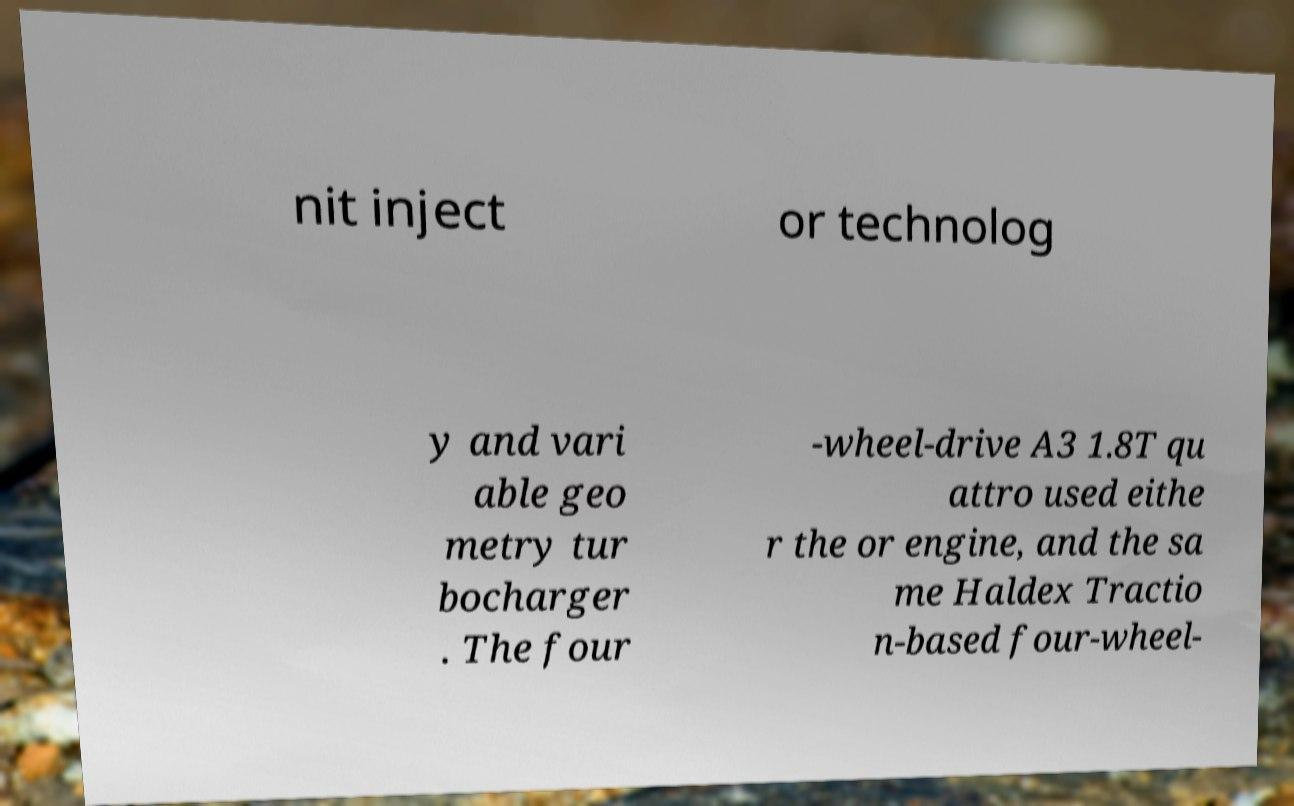Can you accurately transcribe the text from the provided image for me? nit inject or technolog y and vari able geo metry tur bocharger . The four -wheel-drive A3 1.8T qu attro used eithe r the or engine, and the sa me Haldex Tractio n-based four-wheel- 